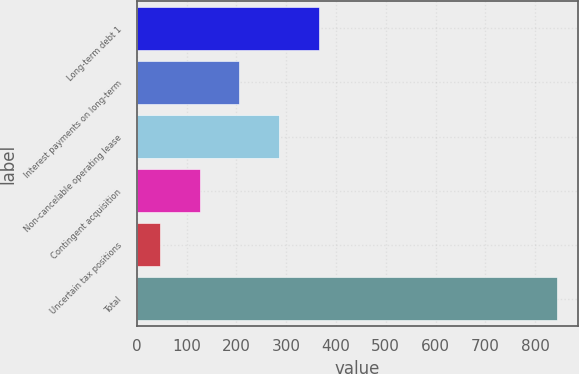Convert chart to OTSL. <chart><loc_0><loc_0><loc_500><loc_500><bar_chart><fcel>Long-term debt 1<fcel>Interest payments on long-term<fcel>Non-cancelable operating lease<fcel>Contingent acquisition<fcel>Uncertain tax positions<fcel>Total<nl><fcel>365.48<fcel>205.94<fcel>285.71<fcel>126.17<fcel>46.4<fcel>844.1<nl></chart> 